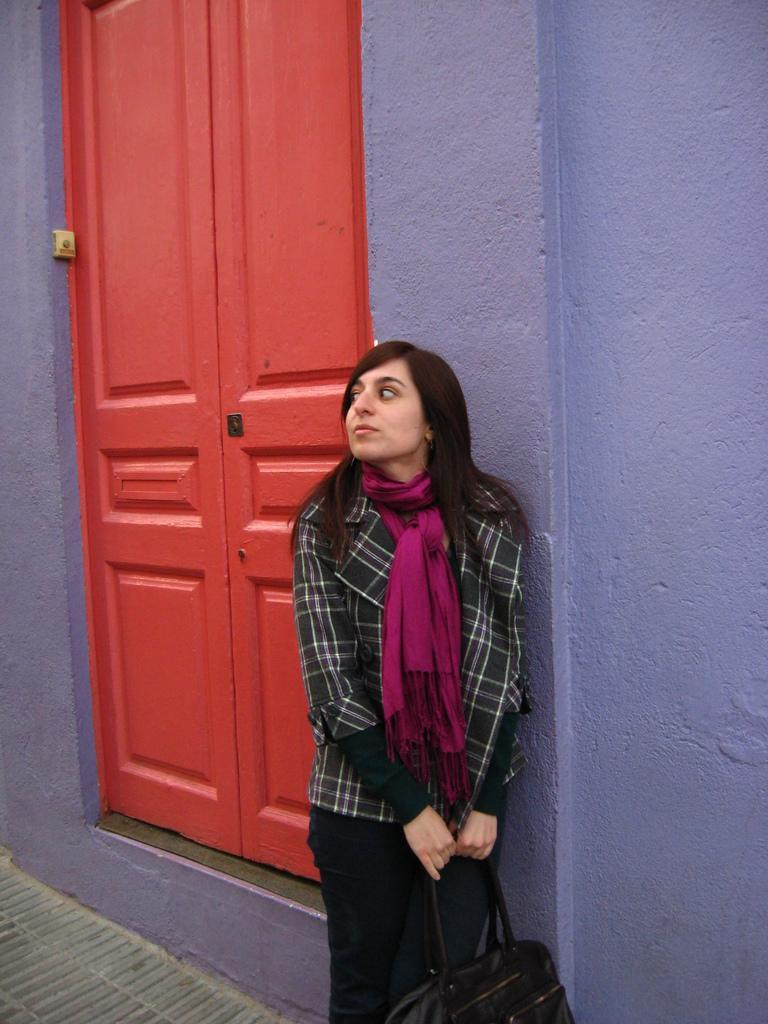How would you summarize this image in a sentence or two? In this image we can see a woman is standing at the wall and holding a bag in her hands. In the background we can see doors and an object on the wall at the door. 